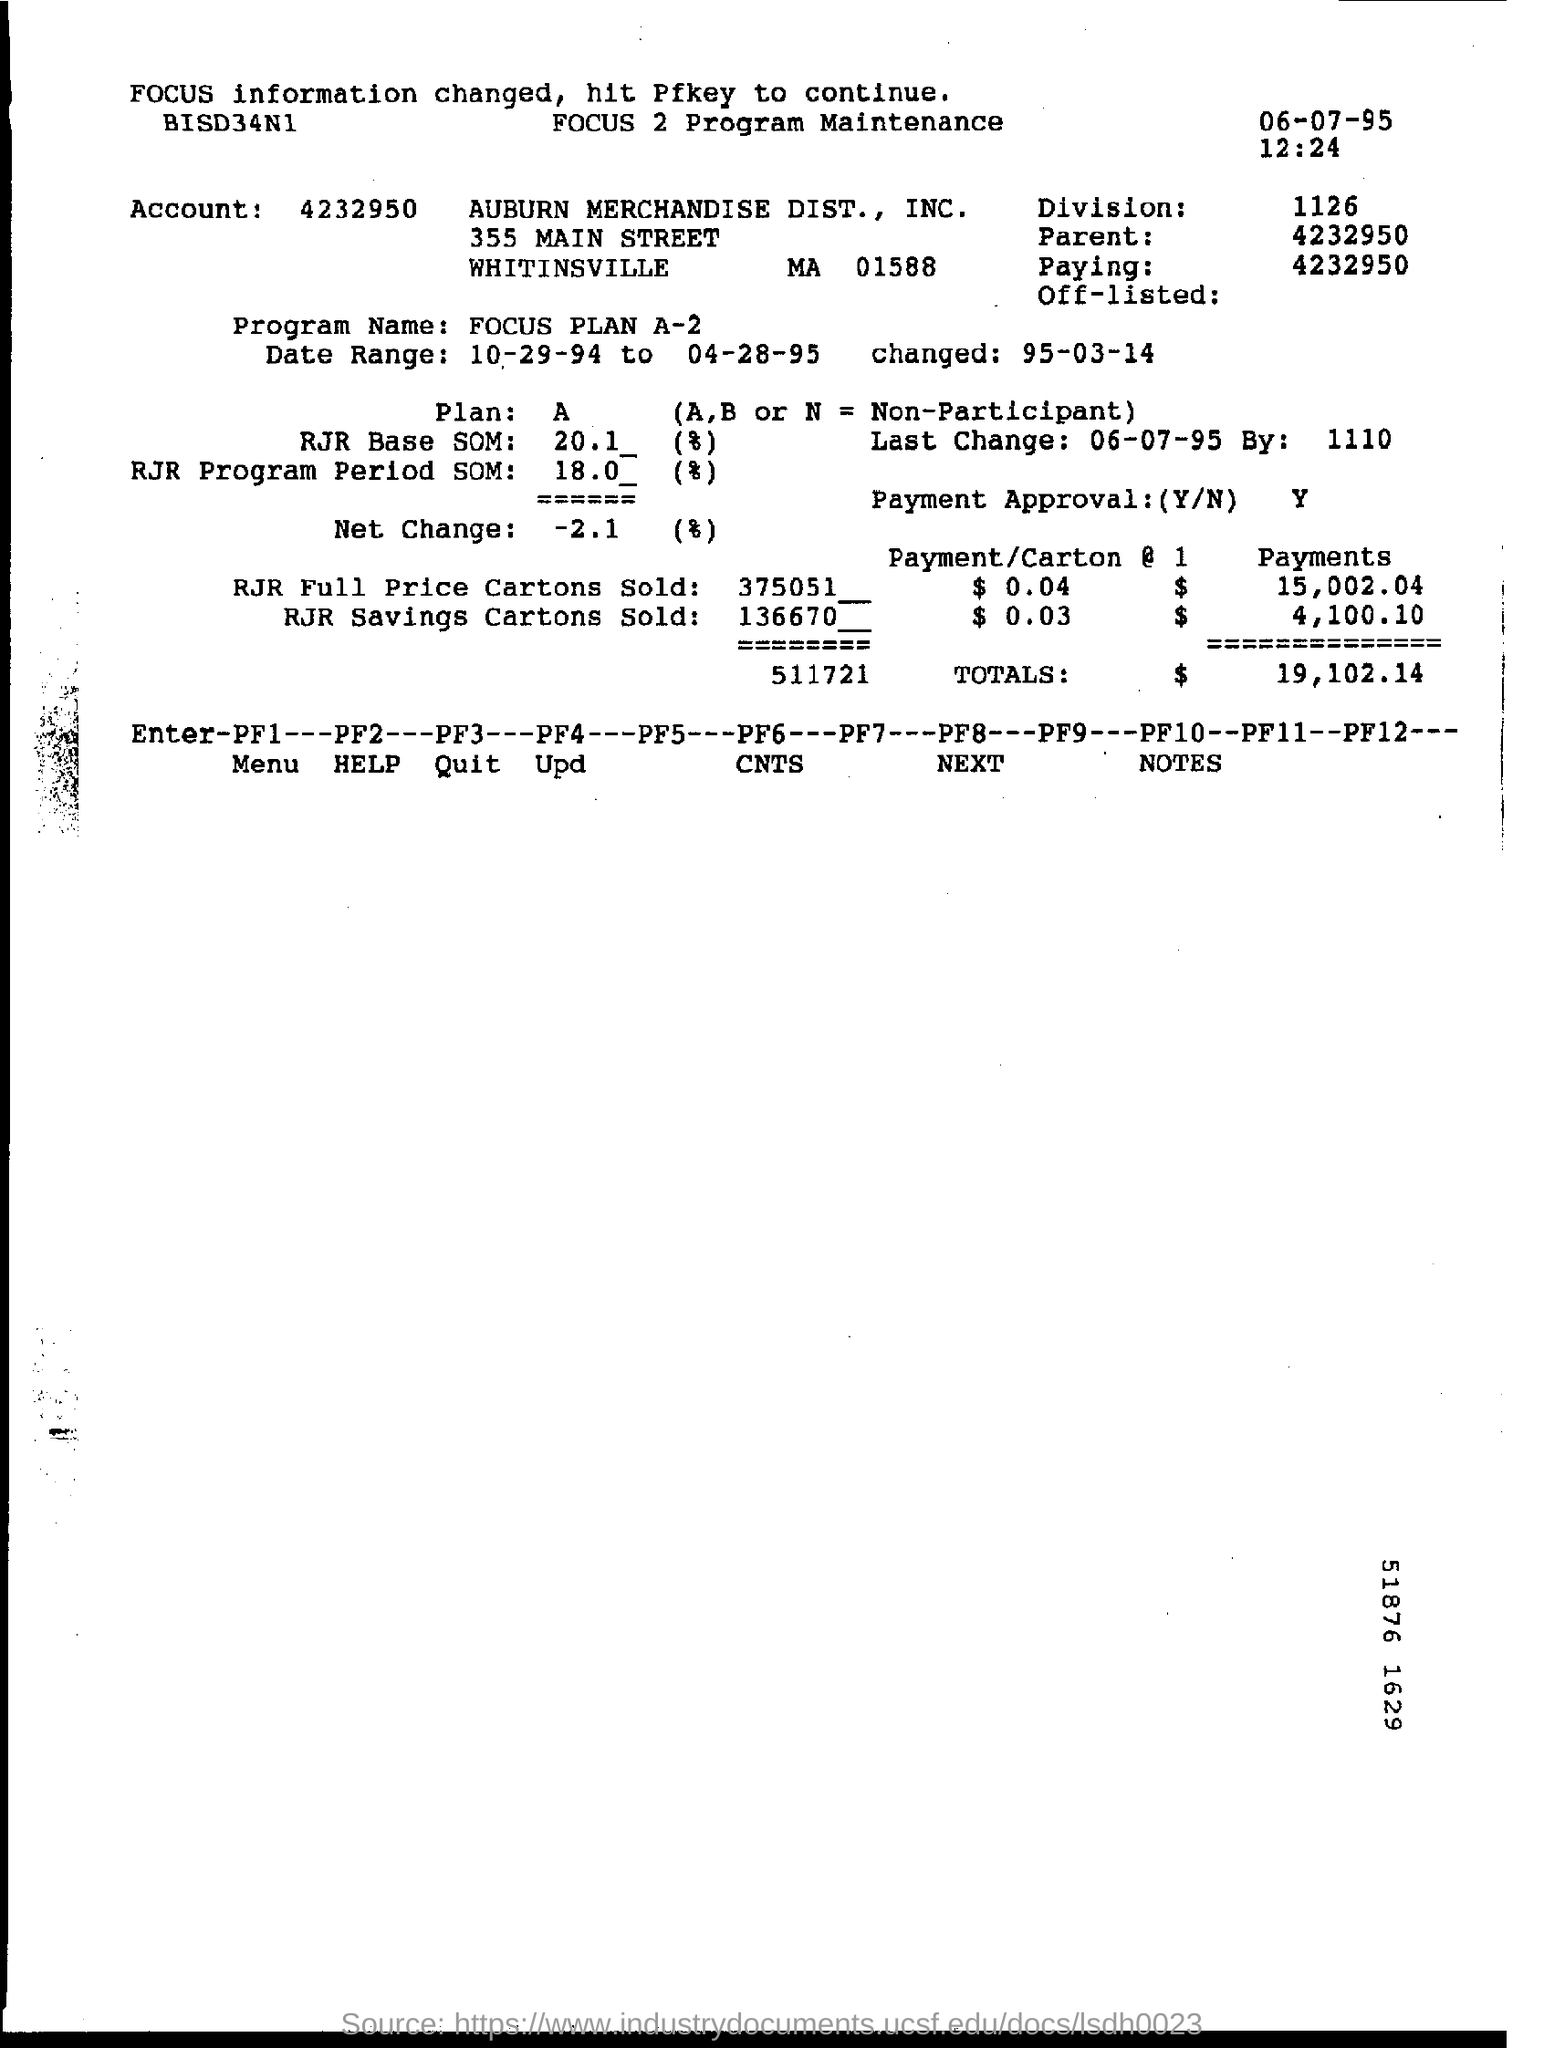What is the account no?
Give a very brief answer. 4232950. What is the date mentioned?
Offer a very short reply. 06-07-95. What is the time mentioned in the document?
Your response must be concise. 12:24. What is the division number?
Your answer should be very brief. 1126. 